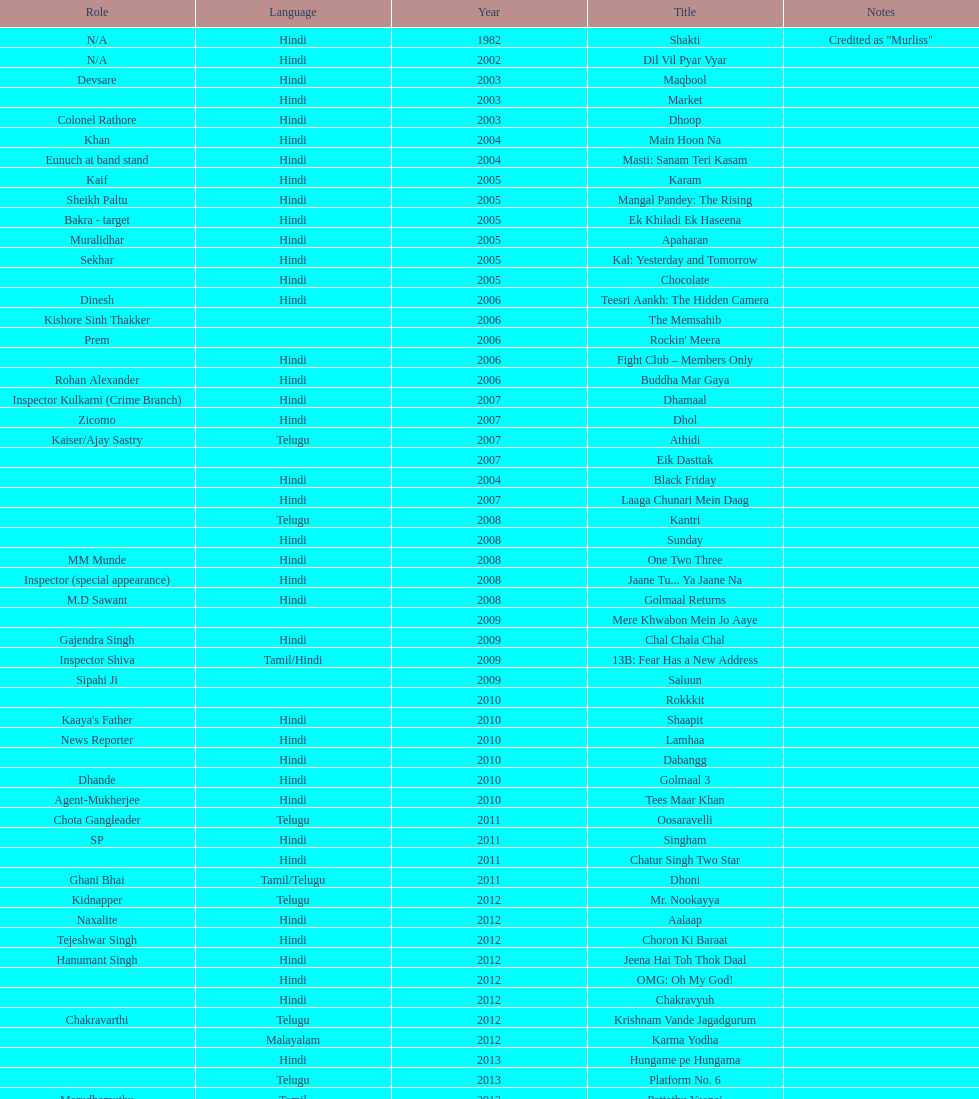What was the last malayalam film this actor starred in? Karma Yodha. 